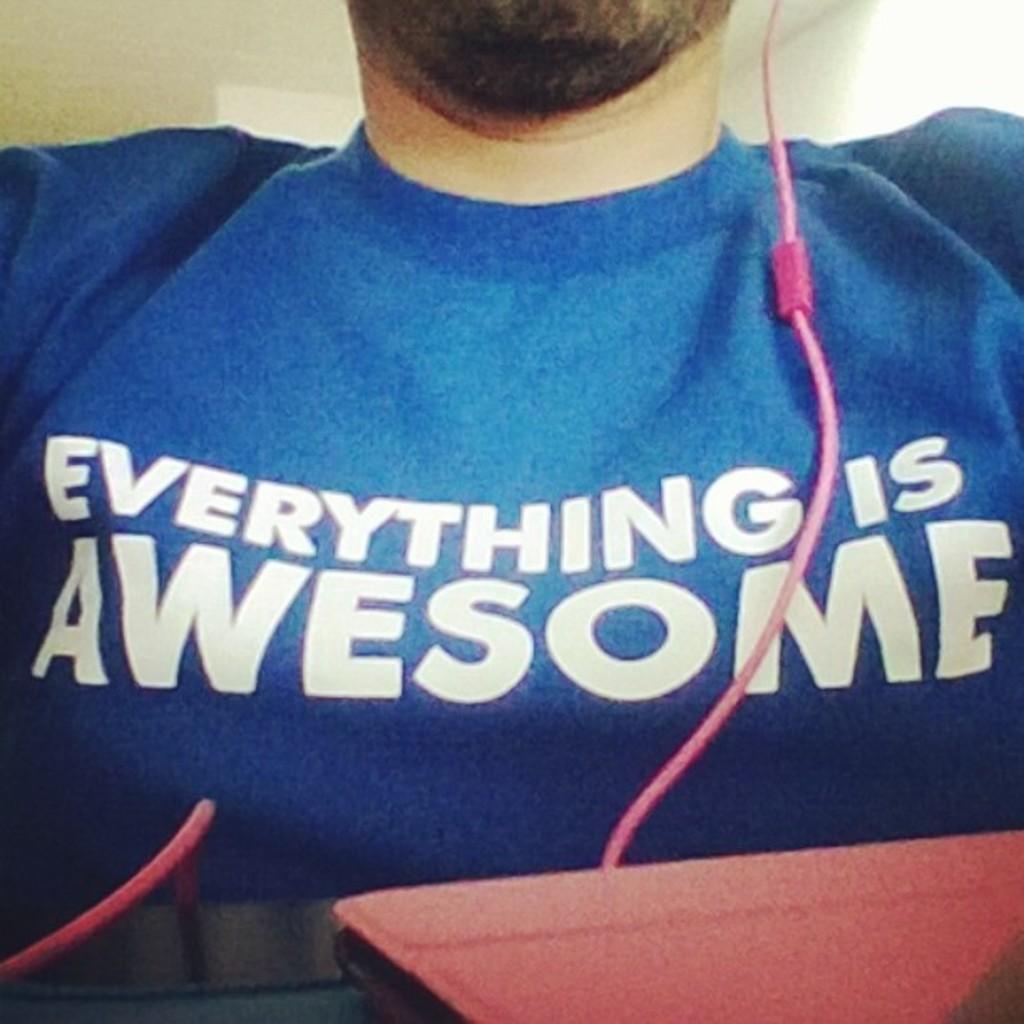What does his shirt say ?
Your response must be concise. Everything is awesome. 